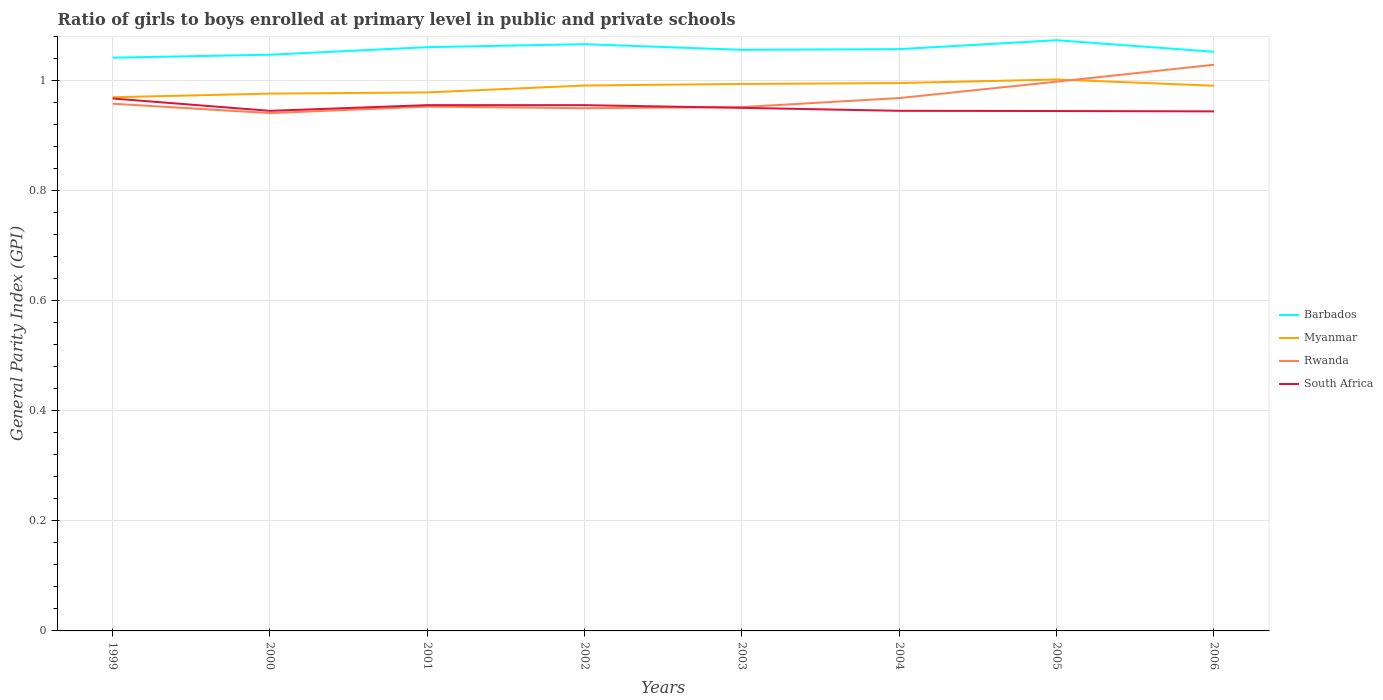How many different coloured lines are there?
Your response must be concise. 4. Does the line corresponding to South Africa intersect with the line corresponding to Barbados?
Provide a short and direct response. No. Across all years, what is the maximum general parity index in Rwanda?
Ensure brevity in your answer.  0.94. What is the total general parity index in Myanmar in the graph?
Your response must be concise. -0.02. What is the difference between the highest and the second highest general parity index in Barbados?
Give a very brief answer. 0.03. Does the graph contain any zero values?
Offer a very short reply. No. How are the legend labels stacked?
Provide a short and direct response. Vertical. What is the title of the graph?
Offer a very short reply. Ratio of girls to boys enrolled at primary level in public and private schools. What is the label or title of the Y-axis?
Offer a very short reply. General Parity Index (GPI). What is the General Parity Index (GPI) in Barbados in 1999?
Ensure brevity in your answer.  1.04. What is the General Parity Index (GPI) in Myanmar in 1999?
Keep it short and to the point. 0.97. What is the General Parity Index (GPI) of Rwanda in 1999?
Offer a terse response. 0.96. What is the General Parity Index (GPI) in South Africa in 1999?
Offer a terse response. 0.97. What is the General Parity Index (GPI) in Barbados in 2000?
Provide a short and direct response. 1.05. What is the General Parity Index (GPI) of Myanmar in 2000?
Your response must be concise. 0.98. What is the General Parity Index (GPI) of Rwanda in 2000?
Provide a short and direct response. 0.94. What is the General Parity Index (GPI) in South Africa in 2000?
Your answer should be compact. 0.95. What is the General Parity Index (GPI) in Barbados in 2001?
Provide a short and direct response. 1.06. What is the General Parity Index (GPI) in Myanmar in 2001?
Make the answer very short. 0.98. What is the General Parity Index (GPI) of Rwanda in 2001?
Provide a succinct answer. 0.95. What is the General Parity Index (GPI) of South Africa in 2001?
Offer a very short reply. 0.96. What is the General Parity Index (GPI) in Barbados in 2002?
Make the answer very short. 1.07. What is the General Parity Index (GPI) in Myanmar in 2002?
Make the answer very short. 0.99. What is the General Parity Index (GPI) of Rwanda in 2002?
Give a very brief answer. 0.95. What is the General Parity Index (GPI) of South Africa in 2002?
Your response must be concise. 0.96. What is the General Parity Index (GPI) in Barbados in 2003?
Keep it short and to the point. 1.06. What is the General Parity Index (GPI) in Myanmar in 2003?
Your answer should be compact. 0.99. What is the General Parity Index (GPI) of Rwanda in 2003?
Offer a terse response. 0.95. What is the General Parity Index (GPI) of South Africa in 2003?
Offer a very short reply. 0.95. What is the General Parity Index (GPI) in Barbados in 2004?
Offer a very short reply. 1.06. What is the General Parity Index (GPI) in Myanmar in 2004?
Keep it short and to the point. 1. What is the General Parity Index (GPI) of Rwanda in 2004?
Your answer should be very brief. 0.97. What is the General Parity Index (GPI) of South Africa in 2004?
Ensure brevity in your answer.  0.95. What is the General Parity Index (GPI) of Barbados in 2005?
Your answer should be very brief. 1.07. What is the General Parity Index (GPI) in Myanmar in 2005?
Offer a terse response. 1. What is the General Parity Index (GPI) in Rwanda in 2005?
Your response must be concise. 1. What is the General Parity Index (GPI) of South Africa in 2005?
Offer a terse response. 0.95. What is the General Parity Index (GPI) of Barbados in 2006?
Keep it short and to the point. 1.05. What is the General Parity Index (GPI) of Myanmar in 2006?
Provide a short and direct response. 0.99. What is the General Parity Index (GPI) of Rwanda in 2006?
Keep it short and to the point. 1.03. What is the General Parity Index (GPI) in South Africa in 2006?
Your answer should be compact. 0.94. Across all years, what is the maximum General Parity Index (GPI) of Barbados?
Keep it short and to the point. 1.07. Across all years, what is the maximum General Parity Index (GPI) of Myanmar?
Offer a terse response. 1. Across all years, what is the maximum General Parity Index (GPI) in Rwanda?
Provide a succinct answer. 1.03. Across all years, what is the maximum General Parity Index (GPI) of South Africa?
Your response must be concise. 0.97. Across all years, what is the minimum General Parity Index (GPI) in Barbados?
Keep it short and to the point. 1.04. Across all years, what is the minimum General Parity Index (GPI) of Myanmar?
Your answer should be compact. 0.97. Across all years, what is the minimum General Parity Index (GPI) in Rwanda?
Your answer should be compact. 0.94. Across all years, what is the minimum General Parity Index (GPI) in South Africa?
Your answer should be very brief. 0.94. What is the total General Parity Index (GPI) of Barbados in the graph?
Your answer should be compact. 8.46. What is the total General Parity Index (GPI) of Myanmar in the graph?
Provide a succinct answer. 7.9. What is the total General Parity Index (GPI) of Rwanda in the graph?
Ensure brevity in your answer.  7.75. What is the total General Parity Index (GPI) in South Africa in the graph?
Make the answer very short. 7.61. What is the difference between the General Parity Index (GPI) in Barbados in 1999 and that in 2000?
Give a very brief answer. -0.01. What is the difference between the General Parity Index (GPI) in Myanmar in 1999 and that in 2000?
Give a very brief answer. -0.01. What is the difference between the General Parity Index (GPI) in Rwanda in 1999 and that in 2000?
Ensure brevity in your answer.  0.02. What is the difference between the General Parity Index (GPI) of South Africa in 1999 and that in 2000?
Provide a short and direct response. 0.02. What is the difference between the General Parity Index (GPI) in Barbados in 1999 and that in 2001?
Your answer should be compact. -0.02. What is the difference between the General Parity Index (GPI) in Myanmar in 1999 and that in 2001?
Give a very brief answer. -0.01. What is the difference between the General Parity Index (GPI) of Rwanda in 1999 and that in 2001?
Provide a short and direct response. 0.01. What is the difference between the General Parity Index (GPI) of South Africa in 1999 and that in 2001?
Your answer should be very brief. 0.01. What is the difference between the General Parity Index (GPI) in Barbados in 1999 and that in 2002?
Give a very brief answer. -0.02. What is the difference between the General Parity Index (GPI) in Myanmar in 1999 and that in 2002?
Your answer should be compact. -0.02. What is the difference between the General Parity Index (GPI) of Rwanda in 1999 and that in 2002?
Keep it short and to the point. 0.01. What is the difference between the General Parity Index (GPI) of South Africa in 1999 and that in 2002?
Offer a terse response. 0.01. What is the difference between the General Parity Index (GPI) of Barbados in 1999 and that in 2003?
Your answer should be very brief. -0.01. What is the difference between the General Parity Index (GPI) of Myanmar in 1999 and that in 2003?
Make the answer very short. -0.02. What is the difference between the General Parity Index (GPI) of Rwanda in 1999 and that in 2003?
Your answer should be compact. 0.01. What is the difference between the General Parity Index (GPI) in South Africa in 1999 and that in 2003?
Your answer should be very brief. 0.02. What is the difference between the General Parity Index (GPI) of Barbados in 1999 and that in 2004?
Provide a succinct answer. -0.02. What is the difference between the General Parity Index (GPI) of Myanmar in 1999 and that in 2004?
Make the answer very short. -0.03. What is the difference between the General Parity Index (GPI) of Rwanda in 1999 and that in 2004?
Your answer should be compact. -0.01. What is the difference between the General Parity Index (GPI) in South Africa in 1999 and that in 2004?
Your response must be concise. 0.02. What is the difference between the General Parity Index (GPI) in Barbados in 1999 and that in 2005?
Keep it short and to the point. -0.03. What is the difference between the General Parity Index (GPI) in Myanmar in 1999 and that in 2005?
Keep it short and to the point. -0.03. What is the difference between the General Parity Index (GPI) in Rwanda in 1999 and that in 2005?
Make the answer very short. -0.04. What is the difference between the General Parity Index (GPI) in South Africa in 1999 and that in 2005?
Your answer should be compact. 0.02. What is the difference between the General Parity Index (GPI) in Barbados in 1999 and that in 2006?
Your response must be concise. -0.01. What is the difference between the General Parity Index (GPI) of Myanmar in 1999 and that in 2006?
Offer a terse response. -0.02. What is the difference between the General Parity Index (GPI) in Rwanda in 1999 and that in 2006?
Your response must be concise. -0.07. What is the difference between the General Parity Index (GPI) in South Africa in 1999 and that in 2006?
Ensure brevity in your answer.  0.02. What is the difference between the General Parity Index (GPI) in Barbados in 2000 and that in 2001?
Make the answer very short. -0.01. What is the difference between the General Parity Index (GPI) in Myanmar in 2000 and that in 2001?
Ensure brevity in your answer.  -0. What is the difference between the General Parity Index (GPI) of Rwanda in 2000 and that in 2001?
Give a very brief answer. -0.01. What is the difference between the General Parity Index (GPI) in South Africa in 2000 and that in 2001?
Your answer should be compact. -0.01. What is the difference between the General Parity Index (GPI) of Barbados in 2000 and that in 2002?
Your response must be concise. -0.02. What is the difference between the General Parity Index (GPI) of Myanmar in 2000 and that in 2002?
Give a very brief answer. -0.01. What is the difference between the General Parity Index (GPI) of Rwanda in 2000 and that in 2002?
Your response must be concise. -0.01. What is the difference between the General Parity Index (GPI) of South Africa in 2000 and that in 2002?
Your response must be concise. -0.01. What is the difference between the General Parity Index (GPI) of Barbados in 2000 and that in 2003?
Provide a succinct answer. -0.01. What is the difference between the General Parity Index (GPI) in Myanmar in 2000 and that in 2003?
Your answer should be very brief. -0.02. What is the difference between the General Parity Index (GPI) of Rwanda in 2000 and that in 2003?
Make the answer very short. -0.01. What is the difference between the General Parity Index (GPI) of South Africa in 2000 and that in 2003?
Keep it short and to the point. -0.01. What is the difference between the General Parity Index (GPI) in Barbados in 2000 and that in 2004?
Keep it short and to the point. -0.01. What is the difference between the General Parity Index (GPI) of Myanmar in 2000 and that in 2004?
Make the answer very short. -0.02. What is the difference between the General Parity Index (GPI) in Rwanda in 2000 and that in 2004?
Your answer should be compact. -0.03. What is the difference between the General Parity Index (GPI) of South Africa in 2000 and that in 2004?
Offer a terse response. -0. What is the difference between the General Parity Index (GPI) of Barbados in 2000 and that in 2005?
Your response must be concise. -0.03. What is the difference between the General Parity Index (GPI) of Myanmar in 2000 and that in 2005?
Your response must be concise. -0.03. What is the difference between the General Parity Index (GPI) of Rwanda in 2000 and that in 2005?
Your response must be concise. -0.06. What is the difference between the General Parity Index (GPI) in Barbados in 2000 and that in 2006?
Offer a very short reply. -0.01. What is the difference between the General Parity Index (GPI) in Myanmar in 2000 and that in 2006?
Provide a succinct answer. -0.01. What is the difference between the General Parity Index (GPI) of Rwanda in 2000 and that in 2006?
Your response must be concise. -0.09. What is the difference between the General Parity Index (GPI) of Barbados in 2001 and that in 2002?
Give a very brief answer. -0.01. What is the difference between the General Parity Index (GPI) of Myanmar in 2001 and that in 2002?
Your response must be concise. -0.01. What is the difference between the General Parity Index (GPI) in Rwanda in 2001 and that in 2002?
Your response must be concise. 0. What is the difference between the General Parity Index (GPI) in Barbados in 2001 and that in 2003?
Offer a very short reply. 0. What is the difference between the General Parity Index (GPI) of Myanmar in 2001 and that in 2003?
Your answer should be compact. -0.02. What is the difference between the General Parity Index (GPI) in Rwanda in 2001 and that in 2003?
Your answer should be very brief. 0. What is the difference between the General Parity Index (GPI) of South Africa in 2001 and that in 2003?
Ensure brevity in your answer.  0. What is the difference between the General Parity Index (GPI) in Barbados in 2001 and that in 2004?
Make the answer very short. 0. What is the difference between the General Parity Index (GPI) in Myanmar in 2001 and that in 2004?
Give a very brief answer. -0.02. What is the difference between the General Parity Index (GPI) in Rwanda in 2001 and that in 2004?
Your answer should be compact. -0.02. What is the difference between the General Parity Index (GPI) in South Africa in 2001 and that in 2004?
Make the answer very short. 0.01. What is the difference between the General Parity Index (GPI) of Barbados in 2001 and that in 2005?
Provide a short and direct response. -0.01. What is the difference between the General Parity Index (GPI) of Myanmar in 2001 and that in 2005?
Provide a succinct answer. -0.02. What is the difference between the General Parity Index (GPI) of Rwanda in 2001 and that in 2005?
Your answer should be very brief. -0.05. What is the difference between the General Parity Index (GPI) of South Africa in 2001 and that in 2005?
Your answer should be very brief. 0.01. What is the difference between the General Parity Index (GPI) in Barbados in 2001 and that in 2006?
Offer a terse response. 0.01. What is the difference between the General Parity Index (GPI) of Myanmar in 2001 and that in 2006?
Keep it short and to the point. -0.01. What is the difference between the General Parity Index (GPI) in Rwanda in 2001 and that in 2006?
Offer a terse response. -0.08. What is the difference between the General Parity Index (GPI) of South Africa in 2001 and that in 2006?
Keep it short and to the point. 0.01. What is the difference between the General Parity Index (GPI) of Barbados in 2002 and that in 2003?
Give a very brief answer. 0.01. What is the difference between the General Parity Index (GPI) in Myanmar in 2002 and that in 2003?
Make the answer very short. -0. What is the difference between the General Parity Index (GPI) in Rwanda in 2002 and that in 2003?
Provide a succinct answer. -0. What is the difference between the General Parity Index (GPI) of South Africa in 2002 and that in 2003?
Your response must be concise. 0. What is the difference between the General Parity Index (GPI) in Barbados in 2002 and that in 2004?
Provide a short and direct response. 0.01. What is the difference between the General Parity Index (GPI) of Myanmar in 2002 and that in 2004?
Make the answer very short. -0. What is the difference between the General Parity Index (GPI) of Rwanda in 2002 and that in 2004?
Keep it short and to the point. -0.02. What is the difference between the General Parity Index (GPI) in South Africa in 2002 and that in 2004?
Make the answer very short. 0.01. What is the difference between the General Parity Index (GPI) of Barbados in 2002 and that in 2005?
Your answer should be compact. -0.01. What is the difference between the General Parity Index (GPI) of Myanmar in 2002 and that in 2005?
Ensure brevity in your answer.  -0.01. What is the difference between the General Parity Index (GPI) of Rwanda in 2002 and that in 2005?
Keep it short and to the point. -0.05. What is the difference between the General Parity Index (GPI) in South Africa in 2002 and that in 2005?
Your answer should be very brief. 0.01. What is the difference between the General Parity Index (GPI) in Barbados in 2002 and that in 2006?
Your response must be concise. 0.01. What is the difference between the General Parity Index (GPI) of Rwanda in 2002 and that in 2006?
Offer a very short reply. -0.08. What is the difference between the General Parity Index (GPI) in South Africa in 2002 and that in 2006?
Provide a succinct answer. 0.01. What is the difference between the General Parity Index (GPI) in Barbados in 2003 and that in 2004?
Give a very brief answer. -0. What is the difference between the General Parity Index (GPI) of Myanmar in 2003 and that in 2004?
Offer a very short reply. -0. What is the difference between the General Parity Index (GPI) of Rwanda in 2003 and that in 2004?
Offer a very short reply. -0.02. What is the difference between the General Parity Index (GPI) of South Africa in 2003 and that in 2004?
Provide a succinct answer. 0.01. What is the difference between the General Parity Index (GPI) in Barbados in 2003 and that in 2005?
Your answer should be compact. -0.02. What is the difference between the General Parity Index (GPI) of Myanmar in 2003 and that in 2005?
Keep it short and to the point. -0.01. What is the difference between the General Parity Index (GPI) in Rwanda in 2003 and that in 2005?
Make the answer very short. -0.05. What is the difference between the General Parity Index (GPI) of South Africa in 2003 and that in 2005?
Your response must be concise. 0.01. What is the difference between the General Parity Index (GPI) in Barbados in 2003 and that in 2006?
Ensure brevity in your answer.  0. What is the difference between the General Parity Index (GPI) in Myanmar in 2003 and that in 2006?
Your answer should be very brief. 0. What is the difference between the General Parity Index (GPI) in Rwanda in 2003 and that in 2006?
Offer a very short reply. -0.08. What is the difference between the General Parity Index (GPI) in South Africa in 2003 and that in 2006?
Give a very brief answer. 0.01. What is the difference between the General Parity Index (GPI) in Barbados in 2004 and that in 2005?
Make the answer very short. -0.02. What is the difference between the General Parity Index (GPI) of Myanmar in 2004 and that in 2005?
Your response must be concise. -0.01. What is the difference between the General Parity Index (GPI) of Rwanda in 2004 and that in 2005?
Offer a very short reply. -0.03. What is the difference between the General Parity Index (GPI) in Barbados in 2004 and that in 2006?
Your answer should be very brief. 0. What is the difference between the General Parity Index (GPI) of Myanmar in 2004 and that in 2006?
Provide a succinct answer. 0. What is the difference between the General Parity Index (GPI) in Rwanda in 2004 and that in 2006?
Offer a very short reply. -0.06. What is the difference between the General Parity Index (GPI) of South Africa in 2004 and that in 2006?
Your answer should be very brief. 0. What is the difference between the General Parity Index (GPI) of Barbados in 2005 and that in 2006?
Make the answer very short. 0.02. What is the difference between the General Parity Index (GPI) in Myanmar in 2005 and that in 2006?
Offer a terse response. 0.01. What is the difference between the General Parity Index (GPI) in Rwanda in 2005 and that in 2006?
Your answer should be compact. -0.03. What is the difference between the General Parity Index (GPI) in South Africa in 2005 and that in 2006?
Provide a short and direct response. 0. What is the difference between the General Parity Index (GPI) in Barbados in 1999 and the General Parity Index (GPI) in Myanmar in 2000?
Make the answer very short. 0.07. What is the difference between the General Parity Index (GPI) in Barbados in 1999 and the General Parity Index (GPI) in Rwanda in 2000?
Keep it short and to the point. 0.1. What is the difference between the General Parity Index (GPI) in Barbados in 1999 and the General Parity Index (GPI) in South Africa in 2000?
Keep it short and to the point. 0.1. What is the difference between the General Parity Index (GPI) in Myanmar in 1999 and the General Parity Index (GPI) in Rwanda in 2000?
Make the answer very short. 0.03. What is the difference between the General Parity Index (GPI) in Myanmar in 1999 and the General Parity Index (GPI) in South Africa in 2000?
Give a very brief answer. 0.02. What is the difference between the General Parity Index (GPI) in Rwanda in 1999 and the General Parity Index (GPI) in South Africa in 2000?
Make the answer very short. 0.01. What is the difference between the General Parity Index (GPI) in Barbados in 1999 and the General Parity Index (GPI) in Myanmar in 2001?
Provide a short and direct response. 0.06. What is the difference between the General Parity Index (GPI) of Barbados in 1999 and the General Parity Index (GPI) of Rwanda in 2001?
Provide a short and direct response. 0.09. What is the difference between the General Parity Index (GPI) in Barbados in 1999 and the General Parity Index (GPI) in South Africa in 2001?
Your answer should be very brief. 0.09. What is the difference between the General Parity Index (GPI) of Myanmar in 1999 and the General Parity Index (GPI) of Rwanda in 2001?
Offer a terse response. 0.02. What is the difference between the General Parity Index (GPI) in Myanmar in 1999 and the General Parity Index (GPI) in South Africa in 2001?
Your response must be concise. 0.01. What is the difference between the General Parity Index (GPI) of Rwanda in 1999 and the General Parity Index (GPI) of South Africa in 2001?
Provide a succinct answer. 0. What is the difference between the General Parity Index (GPI) of Barbados in 1999 and the General Parity Index (GPI) of Myanmar in 2002?
Give a very brief answer. 0.05. What is the difference between the General Parity Index (GPI) in Barbados in 1999 and the General Parity Index (GPI) in Rwanda in 2002?
Ensure brevity in your answer.  0.09. What is the difference between the General Parity Index (GPI) of Barbados in 1999 and the General Parity Index (GPI) of South Africa in 2002?
Ensure brevity in your answer.  0.09. What is the difference between the General Parity Index (GPI) of Myanmar in 1999 and the General Parity Index (GPI) of Rwanda in 2002?
Your answer should be compact. 0.02. What is the difference between the General Parity Index (GPI) in Myanmar in 1999 and the General Parity Index (GPI) in South Africa in 2002?
Offer a terse response. 0.01. What is the difference between the General Parity Index (GPI) of Rwanda in 1999 and the General Parity Index (GPI) of South Africa in 2002?
Your answer should be very brief. 0. What is the difference between the General Parity Index (GPI) of Barbados in 1999 and the General Parity Index (GPI) of Myanmar in 2003?
Offer a terse response. 0.05. What is the difference between the General Parity Index (GPI) in Barbados in 1999 and the General Parity Index (GPI) in Rwanda in 2003?
Offer a terse response. 0.09. What is the difference between the General Parity Index (GPI) of Barbados in 1999 and the General Parity Index (GPI) of South Africa in 2003?
Your answer should be very brief. 0.09. What is the difference between the General Parity Index (GPI) of Myanmar in 1999 and the General Parity Index (GPI) of Rwanda in 2003?
Provide a succinct answer. 0.02. What is the difference between the General Parity Index (GPI) of Myanmar in 1999 and the General Parity Index (GPI) of South Africa in 2003?
Give a very brief answer. 0.02. What is the difference between the General Parity Index (GPI) in Rwanda in 1999 and the General Parity Index (GPI) in South Africa in 2003?
Give a very brief answer. 0.01. What is the difference between the General Parity Index (GPI) in Barbados in 1999 and the General Parity Index (GPI) in Myanmar in 2004?
Ensure brevity in your answer.  0.05. What is the difference between the General Parity Index (GPI) of Barbados in 1999 and the General Parity Index (GPI) of Rwanda in 2004?
Make the answer very short. 0.07. What is the difference between the General Parity Index (GPI) of Barbados in 1999 and the General Parity Index (GPI) of South Africa in 2004?
Offer a very short reply. 0.1. What is the difference between the General Parity Index (GPI) of Myanmar in 1999 and the General Parity Index (GPI) of Rwanda in 2004?
Your answer should be compact. 0. What is the difference between the General Parity Index (GPI) in Myanmar in 1999 and the General Parity Index (GPI) in South Africa in 2004?
Your response must be concise. 0.02. What is the difference between the General Parity Index (GPI) in Rwanda in 1999 and the General Parity Index (GPI) in South Africa in 2004?
Make the answer very short. 0.01. What is the difference between the General Parity Index (GPI) of Barbados in 1999 and the General Parity Index (GPI) of Myanmar in 2005?
Provide a short and direct response. 0.04. What is the difference between the General Parity Index (GPI) in Barbados in 1999 and the General Parity Index (GPI) in Rwanda in 2005?
Your answer should be very brief. 0.04. What is the difference between the General Parity Index (GPI) of Barbados in 1999 and the General Parity Index (GPI) of South Africa in 2005?
Your answer should be compact. 0.1. What is the difference between the General Parity Index (GPI) of Myanmar in 1999 and the General Parity Index (GPI) of Rwanda in 2005?
Give a very brief answer. -0.03. What is the difference between the General Parity Index (GPI) in Myanmar in 1999 and the General Parity Index (GPI) in South Africa in 2005?
Your answer should be very brief. 0.03. What is the difference between the General Parity Index (GPI) in Rwanda in 1999 and the General Parity Index (GPI) in South Africa in 2005?
Keep it short and to the point. 0.01. What is the difference between the General Parity Index (GPI) in Barbados in 1999 and the General Parity Index (GPI) in Myanmar in 2006?
Offer a terse response. 0.05. What is the difference between the General Parity Index (GPI) of Barbados in 1999 and the General Parity Index (GPI) of Rwanda in 2006?
Your answer should be very brief. 0.01. What is the difference between the General Parity Index (GPI) in Barbados in 1999 and the General Parity Index (GPI) in South Africa in 2006?
Offer a terse response. 0.1. What is the difference between the General Parity Index (GPI) in Myanmar in 1999 and the General Parity Index (GPI) in Rwanda in 2006?
Make the answer very short. -0.06. What is the difference between the General Parity Index (GPI) of Myanmar in 1999 and the General Parity Index (GPI) of South Africa in 2006?
Ensure brevity in your answer.  0.03. What is the difference between the General Parity Index (GPI) in Rwanda in 1999 and the General Parity Index (GPI) in South Africa in 2006?
Give a very brief answer. 0.01. What is the difference between the General Parity Index (GPI) of Barbados in 2000 and the General Parity Index (GPI) of Myanmar in 2001?
Ensure brevity in your answer.  0.07. What is the difference between the General Parity Index (GPI) of Barbados in 2000 and the General Parity Index (GPI) of Rwanda in 2001?
Offer a very short reply. 0.09. What is the difference between the General Parity Index (GPI) of Barbados in 2000 and the General Parity Index (GPI) of South Africa in 2001?
Offer a terse response. 0.09. What is the difference between the General Parity Index (GPI) of Myanmar in 2000 and the General Parity Index (GPI) of Rwanda in 2001?
Offer a terse response. 0.02. What is the difference between the General Parity Index (GPI) in Myanmar in 2000 and the General Parity Index (GPI) in South Africa in 2001?
Provide a short and direct response. 0.02. What is the difference between the General Parity Index (GPI) in Rwanda in 2000 and the General Parity Index (GPI) in South Africa in 2001?
Keep it short and to the point. -0.01. What is the difference between the General Parity Index (GPI) of Barbados in 2000 and the General Parity Index (GPI) of Myanmar in 2002?
Your answer should be very brief. 0.06. What is the difference between the General Parity Index (GPI) of Barbados in 2000 and the General Parity Index (GPI) of Rwanda in 2002?
Make the answer very short. 0.1. What is the difference between the General Parity Index (GPI) of Barbados in 2000 and the General Parity Index (GPI) of South Africa in 2002?
Provide a succinct answer. 0.09. What is the difference between the General Parity Index (GPI) of Myanmar in 2000 and the General Parity Index (GPI) of Rwanda in 2002?
Offer a terse response. 0.03. What is the difference between the General Parity Index (GPI) of Myanmar in 2000 and the General Parity Index (GPI) of South Africa in 2002?
Offer a very short reply. 0.02. What is the difference between the General Parity Index (GPI) of Rwanda in 2000 and the General Parity Index (GPI) of South Africa in 2002?
Offer a terse response. -0.01. What is the difference between the General Parity Index (GPI) in Barbados in 2000 and the General Parity Index (GPI) in Myanmar in 2003?
Keep it short and to the point. 0.05. What is the difference between the General Parity Index (GPI) of Barbados in 2000 and the General Parity Index (GPI) of Rwanda in 2003?
Your answer should be compact. 0.1. What is the difference between the General Parity Index (GPI) in Barbados in 2000 and the General Parity Index (GPI) in South Africa in 2003?
Provide a short and direct response. 0.1. What is the difference between the General Parity Index (GPI) of Myanmar in 2000 and the General Parity Index (GPI) of Rwanda in 2003?
Your response must be concise. 0.02. What is the difference between the General Parity Index (GPI) in Myanmar in 2000 and the General Parity Index (GPI) in South Africa in 2003?
Provide a short and direct response. 0.03. What is the difference between the General Parity Index (GPI) of Rwanda in 2000 and the General Parity Index (GPI) of South Africa in 2003?
Your answer should be very brief. -0.01. What is the difference between the General Parity Index (GPI) in Barbados in 2000 and the General Parity Index (GPI) in Myanmar in 2004?
Give a very brief answer. 0.05. What is the difference between the General Parity Index (GPI) in Barbados in 2000 and the General Parity Index (GPI) in Rwanda in 2004?
Offer a terse response. 0.08. What is the difference between the General Parity Index (GPI) in Barbados in 2000 and the General Parity Index (GPI) in South Africa in 2004?
Give a very brief answer. 0.1. What is the difference between the General Parity Index (GPI) of Myanmar in 2000 and the General Parity Index (GPI) of Rwanda in 2004?
Give a very brief answer. 0.01. What is the difference between the General Parity Index (GPI) of Myanmar in 2000 and the General Parity Index (GPI) of South Africa in 2004?
Your answer should be compact. 0.03. What is the difference between the General Parity Index (GPI) in Rwanda in 2000 and the General Parity Index (GPI) in South Africa in 2004?
Give a very brief answer. -0. What is the difference between the General Parity Index (GPI) in Barbados in 2000 and the General Parity Index (GPI) in Myanmar in 2005?
Give a very brief answer. 0.05. What is the difference between the General Parity Index (GPI) in Barbados in 2000 and the General Parity Index (GPI) in Rwanda in 2005?
Keep it short and to the point. 0.05. What is the difference between the General Parity Index (GPI) of Barbados in 2000 and the General Parity Index (GPI) of South Africa in 2005?
Provide a succinct answer. 0.1. What is the difference between the General Parity Index (GPI) in Myanmar in 2000 and the General Parity Index (GPI) in Rwanda in 2005?
Offer a very short reply. -0.02. What is the difference between the General Parity Index (GPI) in Myanmar in 2000 and the General Parity Index (GPI) in South Africa in 2005?
Provide a succinct answer. 0.03. What is the difference between the General Parity Index (GPI) in Rwanda in 2000 and the General Parity Index (GPI) in South Africa in 2005?
Your response must be concise. -0. What is the difference between the General Parity Index (GPI) in Barbados in 2000 and the General Parity Index (GPI) in Myanmar in 2006?
Ensure brevity in your answer.  0.06. What is the difference between the General Parity Index (GPI) in Barbados in 2000 and the General Parity Index (GPI) in Rwanda in 2006?
Your answer should be compact. 0.02. What is the difference between the General Parity Index (GPI) of Barbados in 2000 and the General Parity Index (GPI) of South Africa in 2006?
Offer a very short reply. 0.1. What is the difference between the General Parity Index (GPI) of Myanmar in 2000 and the General Parity Index (GPI) of Rwanda in 2006?
Ensure brevity in your answer.  -0.05. What is the difference between the General Parity Index (GPI) of Myanmar in 2000 and the General Parity Index (GPI) of South Africa in 2006?
Make the answer very short. 0.03. What is the difference between the General Parity Index (GPI) of Rwanda in 2000 and the General Parity Index (GPI) of South Africa in 2006?
Your answer should be compact. -0. What is the difference between the General Parity Index (GPI) of Barbados in 2001 and the General Parity Index (GPI) of Myanmar in 2002?
Ensure brevity in your answer.  0.07. What is the difference between the General Parity Index (GPI) in Barbados in 2001 and the General Parity Index (GPI) in Rwanda in 2002?
Give a very brief answer. 0.11. What is the difference between the General Parity Index (GPI) in Barbados in 2001 and the General Parity Index (GPI) in South Africa in 2002?
Your answer should be very brief. 0.11. What is the difference between the General Parity Index (GPI) in Myanmar in 2001 and the General Parity Index (GPI) in Rwanda in 2002?
Provide a succinct answer. 0.03. What is the difference between the General Parity Index (GPI) in Myanmar in 2001 and the General Parity Index (GPI) in South Africa in 2002?
Ensure brevity in your answer.  0.02. What is the difference between the General Parity Index (GPI) in Rwanda in 2001 and the General Parity Index (GPI) in South Africa in 2002?
Provide a short and direct response. -0. What is the difference between the General Parity Index (GPI) in Barbados in 2001 and the General Parity Index (GPI) in Myanmar in 2003?
Your answer should be compact. 0.07. What is the difference between the General Parity Index (GPI) in Barbados in 2001 and the General Parity Index (GPI) in Rwanda in 2003?
Provide a succinct answer. 0.11. What is the difference between the General Parity Index (GPI) in Barbados in 2001 and the General Parity Index (GPI) in South Africa in 2003?
Your answer should be compact. 0.11. What is the difference between the General Parity Index (GPI) in Myanmar in 2001 and the General Parity Index (GPI) in Rwanda in 2003?
Offer a very short reply. 0.03. What is the difference between the General Parity Index (GPI) in Myanmar in 2001 and the General Parity Index (GPI) in South Africa in 2003?
Give a very brief answer. 0.03. What is the difference between the General Parity Index (GPI) in Rwanda in 2001 and the General Parity Index (GPI) in South Africa in 2003?
Your answer should be very brief. 0. What is the difference between the General Parity Index (GPI) in Barbados in 2001 and the General Parity Index (GPI) in Myanmar in 2004?
Provide a short and direct response. 0.07. What is the difference between the General Parity Index (GPI) in Barbados in 2001 and the General Parity Index (GPI) in Rwanda in 2004?
Make the answer very short. 0.09. What is the difference between the General Parity Index (GPI) of Barbados in 2001 and the General Parity Index (GPI) of South Africa in 2004?
Provide a succinct answer. 0.12. What is the difference between the General Parity Index (GPI) of Myanmar in 2001 and the General Parity Index (GPI) of Rwanda in 2004?
Keep it short and to the point. 0.01. What is the difference between the General Parity Index (GPI) in Myanmar in 2001 and the General Parity Index (GPI) in South Africa in 2004?
Keep it short and to the point. 0.03. What is the difference between the General Parity Index (GPI) of Rwanda in 2001 and the General Parity Index (GPI) of South Africa in 2004?
Make the answer very short. 0.01. What is the difference between the General Parity Index (GPI) of Barbados in 2001 and the General Parity Index (GPI) of Myanmar in 2005?
Your answer should be compact. 0.06. What is the difference between the General Parity Index (GPI) of Barbados in 2001 and the General Parity Index (GPI) of Rwanda in 2005?
Give a very brief answer. 0.06. What is the difference between the General Parity Index (GPI) in Barbados in 2001 and the General Parity Index (GPI) in South Africa in 2005?
Offer a very short reply. 0.12. What is the difference between the General Parity Index (GPI) in Myanmar in 2001 and the General Parity Index (GPI) in Rwanda in 2005?
Offer a very short reply. -0.02. What is the difference between the General Parity Index (GPI) in Myanmar in 2001 and the General Parity Index (GPI) in South Africa in 2005?
Your response must be concise. 0.03. What is the difference between the General Parity Index (GPI) of Rwanda in 2001 and the General Parity Index (GPI) of South Africa in 2005?
Provide a succinct answer. 0.01. What is the difference between the General Parity Index (GPI) in Barbados in 2001 and the General Parity Index (GPI) in Myanmar in 2006?
Provide a succinct answer. 0.07. What is the difference between the General Parity Index (GPI) of Barbados in 2001 and the General Parity Index (GPI) of Rwanda in 2006?
Your answer should be compact. 0.03. What is the difference between the General Parity Index (GPI) in Barbados in 2001 and the General Parity Index (GPI) in South Africa in 2006?
Your response must be concise. 0.12. What is the difference between the General Parity Index (GPI) of Myanmar in 2001 and the General Parity Index (GPI) of Rwanda in 2006?
Make the answer very short. -0.05. What is the difference between the General Parity Index (GPI) of Myanmar in 2001 and the General Parity Index (GPI) of South Africa in 2006?
Offer a very short reply. 0.03. What is the difference between the General Parity Index (GPI) of Rwanda in 2001 and the General Parity Index (GPI) of South Africa in 2006?
Provide a short and direct response. 0.01. What is the difference between the General Parity Index (GPI) in Barbados in 2002 and the General Parity Index (GPI) in Myanmar in 2003?
Provide a succinct answer. 0.07. What is the difference between the General Parity Index (GPI) in Barbados in 2002 and the General Parity Index (GPI) in Rwanda in 2003?
Offer a very short reply. 0.11. What is the difference between the General Parity Index (GPI) in Barbados in 2002 and the General Parity Index (GPI) in South Africa in 2003?
Offer a terse response. 0.12. What is the difference between the General Parity Index (GPI) in Myanmar in 2002 and the General Parity Index (GPI) in Rwanda in 2003?
Your response must be concise. 0.04. What is the difference between the General Parity Index (GPI) of Myanmar in 2002 and the General Parity Index (GPI) of South Africa in 2003?
Make the answer very short. 0.04. What is the difference between the General Parity Index (GPI) in Rwanda in 2002 and the General Parity Index (GPI) in South Africa in 2003?
Make the answer very short. -0. What is the difference between the General Parity Index (GPI) in Barbados in 2002 and the General Parity Index (GPI) in Myanmar in 2004?
Make the answer very short. 0.07. What is the difference between the General Parity Index (GPI) of Barbados in 2002 and the General Parity Index (GPI) of Rwanda in 2004?
Give a very brief answer. 0.1. What is the difference between the General Parity Index (GPI) of Barbados in 2002 and the General Parity Index (GPI) of South Africa in 2004?
Offer a terse response. 0.12. What is the difference between the General Parity Index (GPI) of Myanmar in 2002 and the General Parity Index (GPI) of Rwanda in 2004?
Offer a very short reply. 0.02. What is the difference between the General Parity Index (GPI) in Myanmar in 2002 and the General Parity Index (GPI) in South Africa in 2004?
Your answer should be very brief. 0.05. What is the difference between the General Parity Index (GPI) in Rwanda in 2002 and the General Parity Index (GPI) in South Africa in 2004?
Keep it short and to the point. 0. What is the difference between the General Parity Index (GPI) in Barbados in 2002 and the General Parity Index (GPI) in Myanmar in 2005?
Offer a very short reply. 0.06. What is the difference between the General Parity Index (GPI) in Barbados in 2002 and the General Parity Index (GPI) in Rwanda in 2005?
Provide a succinct answer. 0.07. What is the difference between the General Parity Index (GPI) in Barbados in 2002 and the General Parity Index (GPI) in South Africa in 2005?
Ensure brevity in your answer.  0.12. What is the difference between the General Parity Index (GPI) of Myanmar in 2002 and the General Parity Index (GPI) of Rwanda in 2005?
Ensure brevity in your answer.  -0.01. What is the difference between the General Parity Index (GPI) of Myanmar in 2002 and the General Parity Index (GPI) of South Africa in 2005?
Offer a terse response. 0.05. What is the difference between the General Parity Index (GPI) in Rwanda in 2002 and the General Parity Index (GPI) in South Africa in 2005?
Keep it short and to the point. 0.01. What is the difference between the General Parity Index (GPI) in Barbados in 2002 and the General Parity Index (GPI) in Myanmar in 2006?
Your response must be concise. 0.08. What is the difference between the General Parity Index (GPI) in Barbados in 2002 and the General Parity Index (GPI) in Rwanda in 2006?
Give a very brief answer. 0.04. What is the difference between the General Parity Index (GPI) of Barbados in 2002 and the General Parity Index (GPI) of South Africa in 2006?
Keep it short and to the point. 0.12. What is the difference between the General Parity Index (GPI) in Myanmar in 2002 and the General Parity Index (GPI) in Rwanda in 2006?
Offer a terse response. -0.04. What is the difference between the General Parity Index (GPI) of Myanmar in 2002 and the General Parity Index (GPI) of South Africa in 2006?
Offer a terse response. 0.05. What is the difference between the General Parity Index (GPI) of Rwanda in 2002 and the General Parity Index (GPI) of South Africa in 2006?
Keep it short and to the point. 0.01. What is the difference between the General Parity Index (GPI) of Barbados in 2003 and the General Parity Index (GPI) of Myanmar in 2004?
Offer a very short reply. 0.06. What is the difference between the General Parity Index (GPI) in Barbados in 2003 and the General Parity Index (GPI) in Rwanda in 2004?
Your answer should be compact. 0.09. What is the difference between the General Parity Index (GPI) of Barbados in 2003 and the General Parity Index (GPI) of South Africa in 2004?
Your answer should be compact. 0.11. What is the difference between the General Parity Index (GPI) of Myanmar in 2003 and the General Parity Index (GPI) of Rwanda in 2004?
Your answer should be compact. 0.03. What is the difference between the General Parity Index (GPI) of Myanmar in 2003 and the General Parity Index (GPI) of South Africa in 2004?
Ensure brevity in your answer.  0.05. What is the difference between the General Parity Index (GPI) of Rwanda in 2003 and the General Parity Index (GPI) of South Africa in 2004?
Provide a short and direct response. 0.01. What is the difference between the General Parity Index (GPI) in Barbados in 2003 and the General Parity Index (GPI) in Myanmar in 2005?
Your answer should be compact. 0.05. What is the difference between the General Parity Index (GPI) in Barbados in 2003 and the General Parity Index (GPI) in Rwanda in 2005?
Make the answer very short. 0.06. What is the difference between the General Parity Index (GPI) of Barbados in 2003 and the General Parity Index (GPI) of South Africa in 2005?
Ensure brevity in your answer.  0.11. What is the difference between the General Parity Index (GPI) in Myanmar in 2003 and the General Parity Index (GPI) in Rwanda in 2005?
Your answer should be compact. -0. What is the difference between the General Parity Index (GPI) of Myanmar in 2003 and the General Parity Index (GPI) of South Africa in 2005?
Your answer should be very brief. 0.05. What is the difference between the General Parity Index (GPI) of Rwanda in 2003 and the General Parity Index (GPI) of South Africa in 2005?
Make the answer very short. 0.01. What is the difference between the General Parity Index (GPI) of Barbados in 2003 and the General Parity Index (GPI) of Myanmar in 2006?
Offer a terse response. 0.07. What is the difference between the General Parity Index (GPI) of Barbados in 2003 and the General Parity Index (GPI) of Rwanda in 2006?
Your answer should be very brief. 0.03. What is the difference between the General Parity Index (GPI) in Barbados in 2003 and the General Parity Index (GPI) in South Africa in 2006?
Your answer should be compact. 0.11. What is the difference between the General Parity Index (GPI) in Myanmar in 2003 and the General Parity Index (GPI) in Rwanda in 2006?
Your answer should be very brief. -0.03. What is the difference between the General Parity Index (GPI) in Myanmar in 2003 and the General Parity Index (GPI) in South Africa in 2006?
Provide a succinct answer. 0.05. What is the difference between the General Parity Index (GPI) of Rwanda in 2003 and the General Parity Index (GPI) of South Africa in 2006?
Offer a very short reply. 0.01. What is the difference between the General Parity Index (GPI) of Barbados in 2004 and the General Parity Index (GPI) of Myanmar in 2005?
Provide a short and direct response. 0.06. What is the difference between the General Parity Index (GPI) of Barbados in 2004 and the General Parity Index (GPI) of Rwanda in 2005?
Offer a very short reply. 0.06. What is the difference between the General Parity Index (GPI) in Barbados in 2004 and the General Parity Index (GPI) in South Africa in 2005?
Offer a terse response. 0.11. What is the difference between the General Parity Index (GPI) of Myanmar in 2004 and the General Parity Index (GPI) of Rwanda in 2005?
Make the answer very short. -0. What is the difference between the General Parity Index (GPI) of Myanmar in 2004 and the General Parity Index (GPI) of South Africa in 2005?
Ensure brevity in your answer.  0.05. What is the difference between the General Parity Index (GPI) of Rwanda in 2004 and the General Parity Index (GPI) of South Africa in 2005?
Give a very brief answer. 0.02. What is the difference between the General Parity Index (GPI) in Barbados in 2004 and the General Parity Index (GPI) in Myanmar in 2006?
Provide a short and direct response. 0.07. What is the difference between the General Parity Index (GPI) in Barbados in 2004 and the General Parity Index (GPI) in Rwanda in 2006?
Give a very brief answer. 0.03. What is the difference between the General Parity Index (GPI) of Barbados in 2004 and the General Parity Index (GPI) of South Africa in 2006?
Give a very brief answer. 0.11. What is the difference between the General Parity Index (GPI) of Myanmar in 2004 and the General Parity Index (GPI) of Rwanda in 2006?
Provide a succinct answer. -0.03. What is the difference between the General Parity Index (GPI) of Myanmar in 2004 and the General Parity Index (GPI) of South Africa in 2006?
Offer a very short reply. 0.05. What is the difference between the General Parity Index (GPI) in Rwanda in 2004 and the General Parity Index (GPI) in South Africa in 2006?
Your answer should be compact. 0.02. What is the difference between the General Parity Index (GPI) of Barbados in 2005 and the General Parity Index (GPI) of Myanmar in 2006?
Keep it short and to the point. 0.08. What is the difference between the General Parity Index (GPI) in Barbados in 2005 and the General Parity Index (GPI) in Rwanda in 2006?
Make the answer very short. 0.04. What is the difference between the General Parity Index (GPI) in Barbados in 2005 and the General Parity Index (GPI) in South Africa in 2006?
Provide a short and direct response. 0.13. What is the difference between the General Parity Index (GPI) of Myanmar in 2005 and the General Parity Index (GPI) of Rwanda in 2006?
Make the answer very short. -0.03. What is the difference between the General Parity Index (GPI) in Myanmar in 2005 and the General Parity Index (GPI) in South Africa in 2006?
Offer a terse response. 0.06. What is the difference between the General Parity Index (GPI) of Rwanda in 2005 and the General Parity Index (GPI) of South Africa in 2006?
Provide a short and direct response. 0.05. What is the average General Parity Index (GPI) of Barbados per year?
Offer a very short reply. 1.06. What is the average General Parity Index (GPI) of Myanmar per year?
Your response must be concise. 0.99. What is the average General Parity Index (GPI) of Rwanda per year?
Your response must be concise. 0.97. What is the average General Parity Index (GPI) in South Africa per year?
Ensure brevity in your answer.  0.95. In the year 1999, what is the difference between the General Parity Index (GPI) of Barbados and General Parity Index (GPI) of Myanmar?
Provide a short and direct response. 0.07. In the year 1999, what is the difference between the General Parity Index (GPI) in Barbados and General Parity Index (GPI) in Rwanda?
Your response must be concise. 0.08. In the year 1999, what is the difference between the General Parity Index (GPI) of Barbados and General Parity Index (GPI) of South Africa?
Offer a very short reply. 0.07. In the year 1999, what is the difference between the General Parity Index (GPI) of Myanmar and General Parity Index (GPI) of Rwanda?
Your answer should be compact. 0.01. In the year 1999, what is the difference between the General Parity Index (GPI) in Myanmar and General Parity Index (GPI) in South Africa?
Your answer should be very brief. 0. In the year 1999, what is the difference between the General Parity Index (GPI) in Rwanda and General Parity Index (GPI) in South Africa?
Your answer should be compact. -0.01. In the year 2000, what is the difference between the General Parity Index (GPI) of Barbados and General Parity Index (GPI) of Myanmar?
Offer a terse response. 0.07. In the year 2000, what is the difference between the General Parity Index (GPI) in Barbados and General Parity Index (GPI) in Rwanda?
Keep it short and to the point. 0.11. In the year 2000, what is the difference between the General Parity Index (GPI) of Barbados and General Parity Index (GPI) of South Africa?
Keep it short and to the point. 0.1. In the year 2000, what is the difference between the General Parity Index (GPI) of Myanmar and General Parity Index (GPI) of Rwanda?
Provide a short and direct response. 0.04. In the year 2000, what is the difference between the General Parity Index (GPI) in Myanmar and General Parity Index (GPI) in South Africa?
Provide a succinct answer. 0.03. In the year 2000, what is the difference between the General Parity Index (GPI) in Rwanda and General Parity Index (GPI) in South Africa?
Your answer should be compact. -0. In the year 2001, what is the difference between the General Parity Index (GPI) of Barbados and General Parity Index (GPI) of Myanmar?
Give a very brief answer. 0.08. In the year 2001, what is the difference between the General Parity Index (GPI) of Barbados and General Parity Index (GPI) of Rwanda?
Make the answer very short. 0.11. In the year 2001, what is the difference between the General Parity Index (GPI) in Barbados and General Parity Index (GPI) in South Africa?
Offer a very short reply. 0.11. In the year 2001, what is the difference between the General Parity Index (GPI) in Myanmar and General Parity Index (GPI) in Rwanda?
Keep it short and to the point. 0.03. In the year 2001, what is the difference between the General Parity Index (GPI) of Myanmar and General Parity Index (GPI) of South Africa?
Your response must be concise. 0.02. In the year 2001, what is the difference between the General Parity Index (GPI) in Rwanda and General Parity Index (GPI) in South Africa?
Your answer should be very brief. -0. In the year 2002, what is the difference between the General Parity Index (GPI) of Barbados and General Parity Index (GPI) of Myanmar?
Your answer should be very brief. 0.08. In the year 2002, what is the difference between the General Parity Index (GPI) of Barbados and General Parity Index (GPI) of Rwanda?
Offer a terse response. 0.12. In the year 2002, what is the difference between the General Parity Index (GPI) in Barbados and General Parity Index (GPI) in South Africa?
Offer a very short reply. 0.11. In the year 2002, what is the difference between the General Parity Index (GPI) in Myanmar and General Parity Index (GPI) in Rwanda?
Your answer should be compact. 0.04. In the year 2002, what is the difference between the General Parity Index (GPI) of Myanmar and General Parity Index (GPI) of South Africa?
Your response must be concise. 0.04. In the year 2002, what is the difference between the General Parity Index (GPI) of Rwanda and General Parity Index (GPI) of South Africa?
Your answer should be compact. -0.01. In the year 2003, what is the difference between the General Parity Index (GPI) in Barbados and General Parity Index (GPI) in Myanmar?
Provide a short and direct response. 0.06. In the year 2003, what is the difference between the General Parity Index (GPI) in Barbados and General Parity Index (GPI) in Rwanda?
Provide a succinct answer. 0.1. In the year 2003, what is the difference between the General Parity Index (GPI) of Barbados and General Parity Index (GPI) of South Africa?
Offer a very short reply. 0.11. In the year 2003, what is the difference between the General Parity Index (GPI) of Myanmar and General Parity Index (GPI) of Rwanda?
Provide a succinct answer. 0.04. In the year 2003, what is the difference between the General Parity Index (GPI) in Myanmar and General Parity Index (GPI) in South Africa?
Make the answer very short. 0.04. In the year 2003, what is the difference between the General Parity Index (GPI) in Rwanda and General Parity Index (GPI) in South Africa?
Offer a very short reply. 0. In the year 2004, what is the difference between the General Parity Index (GPI) of Barbados and General Parity Index (GPI) of Myanmar?
Your answer should be compact. 0.06. In the year 2004, what is the difference between the General Parity Index (GPI) of Barbados and General Parity Index (GPI) of Rwanda?
Offer a very short reply. 0.09. In the year 2004, what is the difference between the General Parity Index (GPI) of Barbados and General Parity Index (GPI) of South Africa?
Make the answer very short. 0.11. In the year 2004, what is the difference between the General Parity Index (GPI) of Myanmar and General Parity Index (GPI) of Rwanda?
Offer a terse response. 0.03. In the year 2004, what is the difference between the General Parity Index (GPI) of Myanmar and General Parity Index (GPI) of South Africa?
Your answer should be very brief. 0.05. In the year 2004, what is the difference between the General Parity Index (GPI) of Rwanda and General Parity Index (GPI) of South Africa?
Offer a terse response. 0.02. In the year 2005, what is the difference between the General Parity Index (GPI) in Barbados and General Parity Index (GPI) in Myanmar?
Provide a short and direct response. 0.07. In the year 2005, what is the difference between the General Parity Index (GPI) in Barbados and General Parity Index (GPI) in Rwanda?
Offer a very short reply. 0.08. In the year 2005, what is the difference between the General Parity Index (GPI) of Barbados and General Parity Index (GPI) of South Africa?
Make the answer very short. 0.13. In the year 2005, what is the difference between the General Parity Index (GPI) of Myanmar and General Parity Index (GPI) of Rwanda?
Provide a succinct answer. 0. In the year 2005, what is the difference between the General Parity Index (GPI) of Myanmar and General Parity Index (GPI) of South Africa?
Offer a terse response. 0.06. In the year 2005, what is the difference between the General Parity Index (GPI) in Rwanda and General Parity Index (GPI) in South Africa?
Provide a succinct answer. 0.05. In the year 2006, what is the difference between the General Parity Index (GPI) of Barbados and General Parity Index (GPI) of Myanmar?
Make the answer very short. 0.06. In the year 2006, what is the difference between the General Parity Index (GPI) in Barbados and General Parity Index (GPI) in Rwanda?
Your answer should be compact. 0.02. In the year 2006, what is the difference between the General Parity Index (GPI) of Barbados and General Parity Index (GPI) of South Africa?
Your response must be concise. 0.11. In the year 2006, what is the difference between the General Parity Index (GPI) of Myanmar and General Parity Index (GPI) of Rwanda?
Offer a terse response. -0.04. In the year 2006, what is the difference between the General Parity Index (GPI) of Myanmar and General Parity Index (GPI) of South Africa?
Your answer should be very brief. 0.05. In the year 2006, what is the difference between the General Parity Index (GPI) in Rwanda and General Parity Index (GPI) in South Africa?
Keep it short and to the point. 0.08. What is the ratio of the General Parity Index (GPI) of Barbados in 1999 to that in 2000?
Give a very brief answer. 0.99. What is the ratio of the General Parity Index (GPI) of Rwanda in 1999 to that in 2000?
Your answer should be compact. 1.02. What is the ratio of the General Parity Index (GPI) of South Africa in 1999 to that in 2000?
Provide a succinct answer. 1.02. What is the ratio of the General Parity Index (GPI) in Barbados in 1999 to that in 2001?
Provide a short and direct response. 0.98. What is the ratio of the General Parity Index (GPI) in South Africa in 1999 to that in 2001?
Provide a succinct answer. 1.01. What is the ratio of the General Parity Index (GPI) in Barbados in 1999 to that in 2002?
Provide a succinct answer. 0.98. What is the ratio of the General Parity Index (GPI) in Myanmar in 1999 to that in 2002?
Your answer should be compact. 0.98. What is the ratio of the General Parity Index (GPI) of Rwanda in 1999 to that in 2002?
Your answer should be very brief. 1.01. What is the ratio of the General Parity Index (GPI) in South Africa in 1999 to that in 2002?
Provide a short and direct response. 1.01. What is the ratio of the General Parity Index (GPI) in Barbados in 1999 to that in 2003?
Ensure brevity in your answer.  0.99. What is the ratio of the General Parity Index (GPI) in Myanmar in 1999 to that in 2003?
Give a very brief answer. 0.98. What is the ratio of the General Parity Index (GPI) of South Africa in 1999 to that in 2003?
Make the answer very short. 1.02. What is the ratio of the General Parity Index (GPI) in Barbados in 1999 to that in 2004?
Give a very brief answer. 0.99. What is the ratio of the General Parity Index (GPI) in Myanmar in 1999 to that in 2004?
Your response must be concise. 0.97. What is the ratio of the General Parity Index (GPI) in Rwanda in 1999 to that in 2004?
Provide a short and direct response. 0.99. What is the ratio of the General Parity Index (GPI) in South Africa in 1999 to that in 2004?
Provide a succinct answer. 1.02. What is the ratio of the General Parity Index (GPI) of Barbados in 1999 to that in 2005?
Your answer should be compact. 0.97. What is the ratio of the General Parity Index (GPI) of Myanmar in 1999 to that in 2005?
Offer a terse response. 0.97. What is the ratio of the General Parity Index (GPI) in Rwanda in 1999 to that in 2005?
Ensure brevity in your answer.  0.96. What is the ratio of the General Parity Index (GPI) of South Africa in 1999 to that in 2005?
Offer a very short reply. 1.02. What is the ratio of the General Parity Index (GPI) in Myanmar in 1999 to that in 2006?
Your answer should be very brief. 0.98. What is the ratio of the General Parity Index (GPI) of Rwanda in 1999 to that in 2006?
Give a very brief answer. 0.93. What is the ratio of the General Parity Index (GPI) in South Africa in 1999 to that in 2006?
Offer a very short reply. 1.02. What is the ratio of the General Parity Index (GPI) in Myanmar in 2000 to that in 2001?
Provide a succinct answer. 1. What is the ratio of the General Parity Index (GPI) in South Africa in 2000 to that in 2001?
Keep it short and to the point. 0.99. What is the ratio of the General Parity Index (GPI) of Barbados in 2000 to that in 2002?
Offer a very short reply. 0.98. What is the ratio of the General Parity Index (GPI) of Myanmar in 2000 to that in 2002?
Keep it short and to the point. 0.99. What is the ratio of the General Parity Index (GPI) in Rwanda in 2000 to that in 2002?
Keep it short and to the point. 0.99. What is the ratio of the General Parity Index (GPI) in Barbados in 2000 to that in 2003?
Ensure brevity in your answer.  0.99. What is the ratio of the General Parity Index (GPI) of Myanmar in 2000 to that in 2003?
Provide a succinct answer. 0.98. What is the ratio of the General Parity Index (GPI) in Rwanda in 2000 to that in 2003?
Keep it short and to the point. 0.99. What is the ratio of the General Parity Index (GPI) of Myanmar in 2000 to that in 2004?
Ensure brevity in your answer.  0.98. What is the ratio of the General Parity Index (GPI) in Rwanda in 2000 to that in 2004?
Make the answer very short. 0.97. What is the ratio of the General Parity Index (GPI) of South Africa in 2000 to that in 2004?
Ensure brevity in your answer.  1. What is the ratio of the General Parity Index (GPI) in Barbados in 2000 to that in 2005?
Provide a succinct answer. 0.98. What is the ratio of the General Parity Index (GPI) of Myanmar in 2000 to that in 2005?
Ensure brevity in your answer.  0.97. What is the ratio of the General Parity Index (GPI) in Rwanda in 2000 to that in 2005?
Ensure brevity in your answer.  0.94. What is the ratio of the General Parity Index (GPI) of South Africa in 2000 to that in 2005?
Your answer should be compact. 1. What is the ratio of the General Parity Index (GPI) of Barbados in 2000 to that in 2006?
Ensure brevity in your answer.  0.99. What is the ratio of the General Parity Index (GPI) of Myanmar in 2000 to that in 2006?
Provide a short and direct response. 0.99. What is the ratio of the General Parity Index (GPI) in Rwanda in 2000 to that in 2006?
Ensure brevity in your answer.  0.91. What is the ratio of the General Parity Index (GPI) of South Africa in 2000 to that in 2006?
Your response must be concise. 1. What is the ratio of the General Parity Index (GPI) in Barbados in 2001 to that in 2002?
Keep it short and to the point. 0.99. What is the ratio of the General Parity Index (GPI) of Myanmar in 2001 to that in 2002?
Your response must be concise. 0.99. What is the ratio of the General Parity Index (GPI) in Rwanda in 2001 to that in 2002?
Ensure brevity in your answer.  1. What is the ratio of the General Parity Index (GPI) of Myanmar in 2001 to that in 2003?
Provide a short and direct response. 0.98. What is the ratio of the General Parity Index (GPI) of Myanmar in 2001 to that in 2004?
Your answer should be very brief. 0.98. What is the ratio of the General Parity Index (GPI) of Rwanda in 2001 to that in 2004?
Give a very brief answer. 0.98. What is the ratio of the General Parity Index (GPI) in South Africa in 2001 to that in 2004?
Make the answer very short. 1.01. What is the ratio of the General Parity Index (GPI) of Barbados in 2001 to that in 2005?
Your response must be concise. 0.99. What is the ratio of the General Parity Index (GPI) in Myanmar in 2001 to that in 2005?
Your answer should be very brief. 0.98. What is the ratio of the General Parity Index (GPI) of Rwanda in 2001 to that in 2005?
Give a very brief answer. 0.95. What is the ratio of the General Parity Index (GPI) in South Africa in 2001 to that in 2005?
Provide a succinct answer. 1.01. What is the ratio of the General Parity Index (GPI) of Rwanda in 2001 to that in 2006?
Your answer should be compact. 0.93. What is the ratio of the General Parity Index (GPI) of South Africa in 2001 to that in 2006?
Your answer should be very brief. 1.01. What is the ratio of the General Parity Index (GPI) of Barbados in 2002 to that in 2003?
Give a very brief answer. 1.01. What is the ratio of the General Parity Index (GPI) of Myanmar in 2002 to that in 2003?
Make the answer very short. 1. What is the ratio of the General Parity Index (GPI) in Barbados in 2002 to that in 2004?
Your answer should be very brief. 1.01. What is the ratio of the General Parity Index (GPI) of South Africa in 2002 to that in 2004?
Your response must be concise. 1.01. What is the ratio of the General Parity Index (GPI) of Myanmar in 2002 to that in 2005?
Your answer should be very brief. 0.99. What is the ratio of the General Parity Index (GPI) of Rwanda in 2002 to that in 2005?
Your answer should be compact. 0.95. What is the ratio of the General Parity Index (GPI) in South Africa in 2002 to that in 2005?
Give a very brief answer. 1.01. What is the ratio of the General Parity Index (GPI) of Barbados in 2002 to that in 2006?
Your answer should be compact. 1.01. What is the ratio of the General Parity Index (GPI) of Rwanda in 2002 to that in 2006?
Provide a succinct answer. 0.92. What is the ratio of the General Parity Index (GPI) of South Africa in 2002 to that in 2006?
Your answer should be compact. 1.01. What is the ratio of the General Parity Index (GPI) in Myanmar in 2003 to that in 2004?
Provide a short and direct response. 1. What is the ratio of the General Parity Index (GPI) of South Africa in 2003 to that in 2004?
Give a very brief answer. 1.01. What is the ratio of the General Parity Index (GPI) of Barbados in 2003 to that in 2005?
Provide a short and direct response. 0.98. What is the ratio of the General Parity Index (GPI) of Myanmar in 2003 to that in 2005?
Give a very brief answer. 0.99. What is the ratio of the General Parity Index (GPI) of Rwanda in 2003 to that in 2005?
Offer a very short reply. 0.95. What is the ratio of the General Parity Index (GPI) in South Africa in 2003 to that in 2005?
Offer a very short reply. 1.01. What is the ratio of the General Parity Index (GPI) of Barbados in 2003 to that in 2006?
Provide a short and direct response. 1. What is the ratio of the General Parity Index (GPI) in Myanmar in 2003 to that in 2006?
Your answer should be compact. 1. What is the ratio of the General Parity Index (GPI) in Rwanda in 2003 to that in 2006?
Keep it short and to the point. 0.93. What is the ratio of the General Parity Index (GPI) of South Africa in 2003 to that in 2006?
Ensure brevity in your answer.  1.01. What is the ratio of the General Parity Index (GPI) in Barbados in 2004 to that in 2005?
Ensure brevity in your answer.  0.98. What is the ratio of the General Parity Index (GPI) of Rwanda in 2004 to that in 2005?
Make the answer very short. 0.97. What is the ratio of the General Parity Index (GPI) in Rwanda in 2004 to that in 2006?
Provide a succinct answer. 0.94. What is the ratio of the General Parity Index (GPI) of Myanmar in 2005 to that in 2006?
Keep it short and to the point. 1.01. What is the ratio of the General Parity Index (GPI) in Rwanda in 2005 to that in 2006?
Make the answer very short. 0.97. What is the difference between the highest and the second highest General Parity Index (GPI) of Barbados?
Your answer should be very brief. 0.01. What is the difference between the highest and the second highest General Parity Index (GPI) in Myanmar?
Keep it short and to the point. 0.01. What is the difference between the highest and the second highest General Parity Index (GPI) of Rwanda?
Your answer should be very brief. 0.03. What is the difference between the highest and the second highest General Parity Index (GPI) in South Africa?
Provide a succinct answer. 0.01. What is the difference between the highest and the lowest General Parity Index (GPI) of Barbados?
Ensure brevity in your answer.  0.03. What is the difference between the highest and the lowest General Parity Index (GPI) in Myanmar?
Your answer should be compact. 0.03. What is the difference between the highest and the lowest General Parity Index (GPI) in Rwanda?
Give a very brief answer. 0.09. What is the difference between the highest and the lowest General Parity Index (GPI) of South Africa?
Make the answer very short. 0.02. 